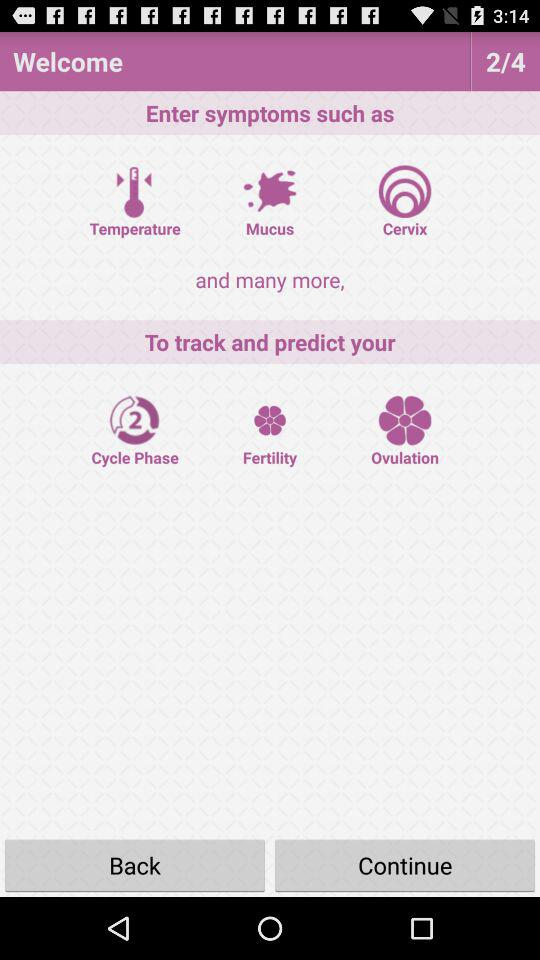What is the current page number? The current page number is 2. 